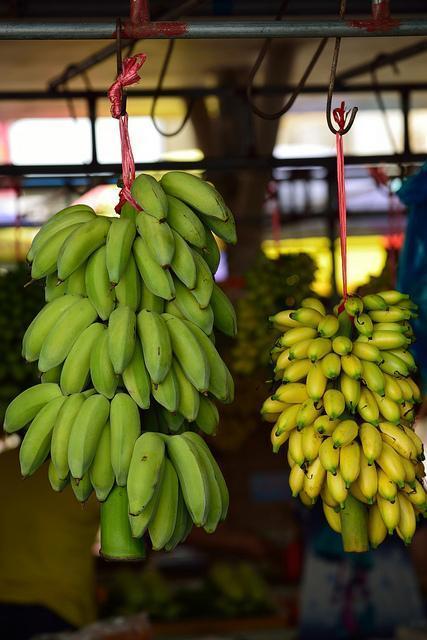How many bananas are there?
Give a very brief answer. 4. 